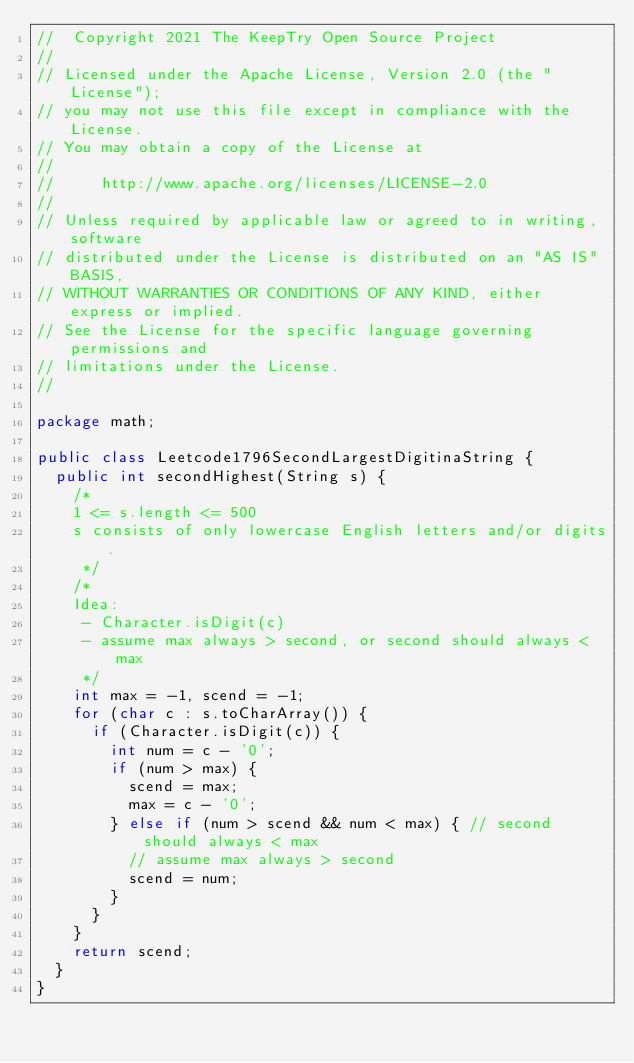<code> <loc_0><loc_0><loc_500><loc_500><_Java_>//  Copyright 2021 The KeepTry Open Source Project
//
// Licensed under the Apache License, Version 2.0 (the "License");
// you may not use this file except in compliance with the License.
// You may obtain a copy of the License at
//
//     http://www.apache.org/licenses/LICENSE-2.0
//
// Unless required by applicable law or agreed to in writing, software
// distributed under the License is distributed on an "AS IS" BASIS,
// WITHOUT WARRANTIES OR CONDITIONS OF ANY KIND, either express or implied.
// See the License for the specific language governing permissions and
// limitations under the License.
//

package math;

public class Leetcode1796SecondLargestDigitinaString {
  public int secondHighest(String s) {
    /*
    1 <= s.length <= 500
    s consists of only lowercase English letters and/or digits.
     */
    /*
    Idea:
     - Character.isDigit(c)
     - assume max always > second, or second should always < max
     */
    int max = -1, scend = -1;
    for (char c : s.toCharArray()) {
      if (Character.isDigit(c)) {
        int num = c - '0';
        if (num > max) {
          scend = max;
          max = c - '0';
        } else if (num > scend && num < max) { // second should always < max
          // assume max always > second
          scend = num;
        }
      }
    }
    return scend;
  }
}
</code> 